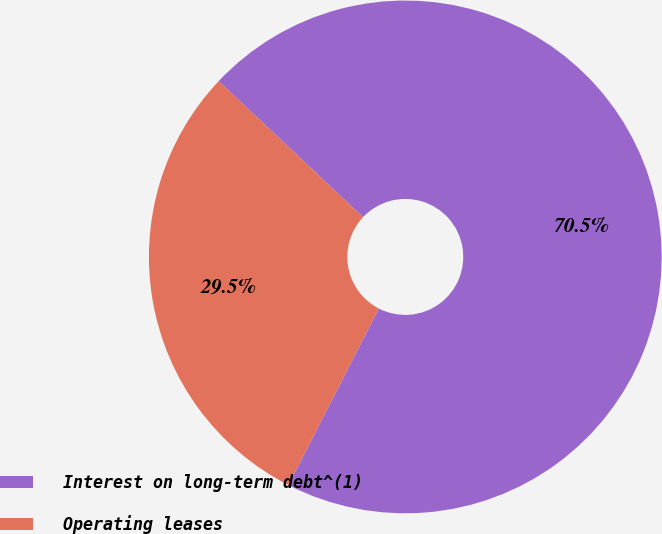Convert chart to OTSL. <chart><loc_0><loc_0><loc_500><loc_500><pie_chart><fcel>Interest on long-term debt^(1)<fcel>Operating leases<nl><fcel>70.51%<fcel>29.49%<nl></chart> 